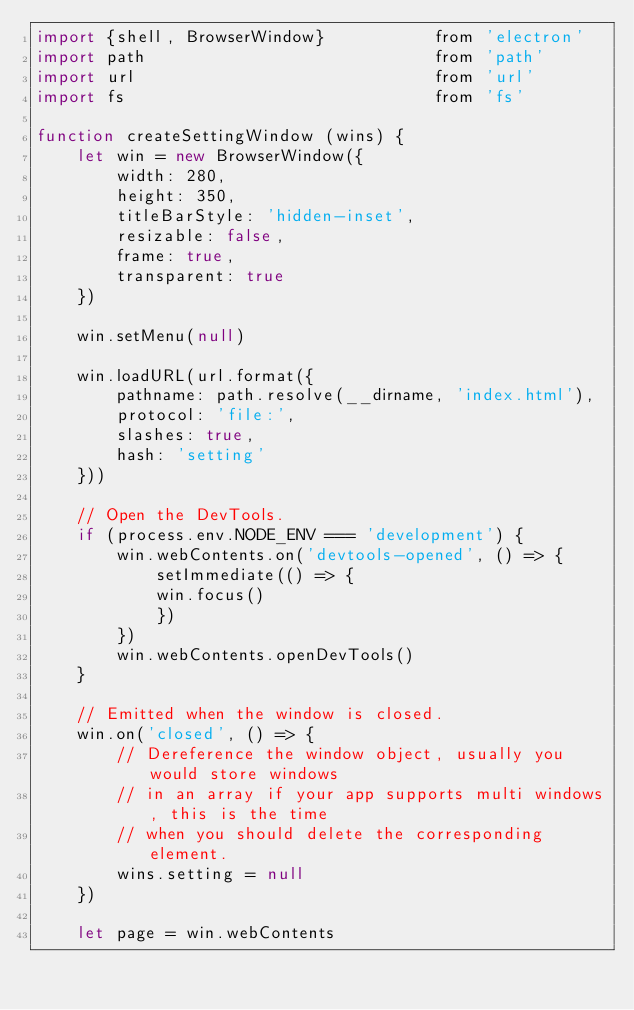<code> <loc_0><loc_0><loc_500><loc_500><_JavaScript_>import {shell, BrowserWindow}           from 'electron'
import path                             from 'path'
import url                              from 'url'
import fs                               from 'fs'

function createSettingWindow (wins) {
    let win = new BrowserWindow({
        width: 280,
        height: 350,
        titleBarStyle: 'hidden-inset',
        resizable: false,
        frame: true,
        transparent: true
    })

    win.setMenu(null)

    win.loadURL(url.format({
        pathname: path.resolve(__dirname, 'index.html'),
        protocol: 'file:',
        slashes: true,
        hash: 'setting'
    }))

    // Open the DevTools.
    if (process.env.NODE_ENV === 'development') {
        win.webContents.on('devtools-opened', () => {
            setImmediate(() => {
            win.focus()
            })
        })
        win.webContents.openDevTools()
    }

    // Emitted when the window is closed.
    win.on('closed', () => {
        // Dereference the window object, usually you would store windows
        // in an array if your app supports multi windows, this is the time
        // when you should delete the corresponding element.
        wins.setting = null
    })

    let page = win.webContents
</code> 